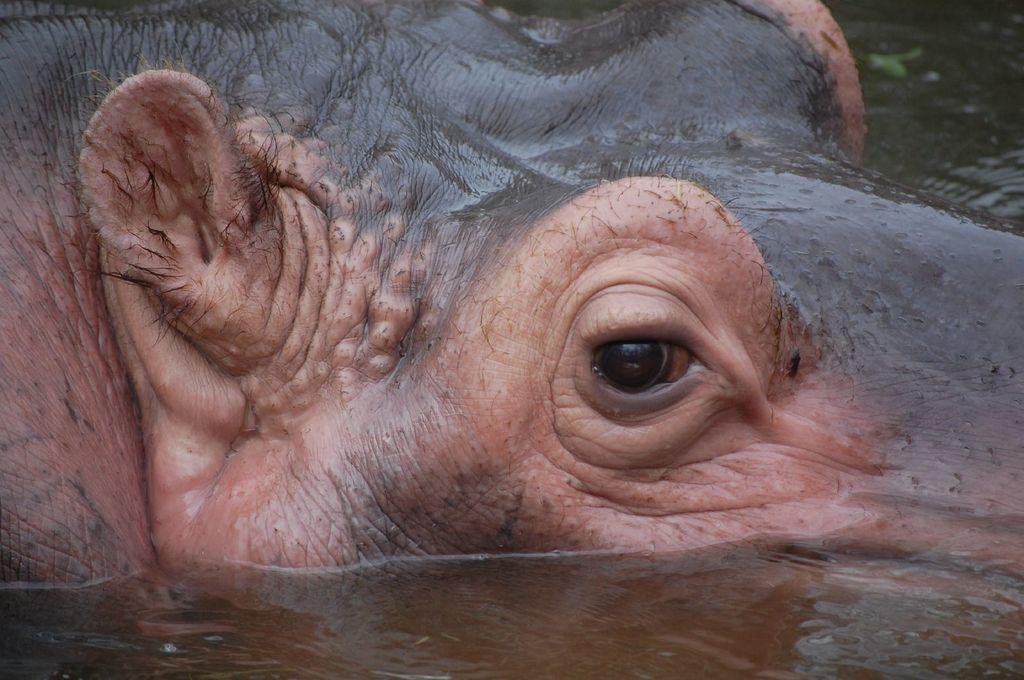What is the main subject of the image? There is an animal in the water in the image. Can you describe the animal in the water? Unfortunately, the specific type of animal cannot be determined from the provided facts. What is the setting of the image? The setting of the image is in or near water, where the animal is present. What type of veil is being worn by the animal in the image? There is no veil present in the image, as it features an animal in the water. Can you describe the taste of the water in the image? The taste of the water cannot be determined from the image, as taste is a sensory experience and not visible in a photograph. 